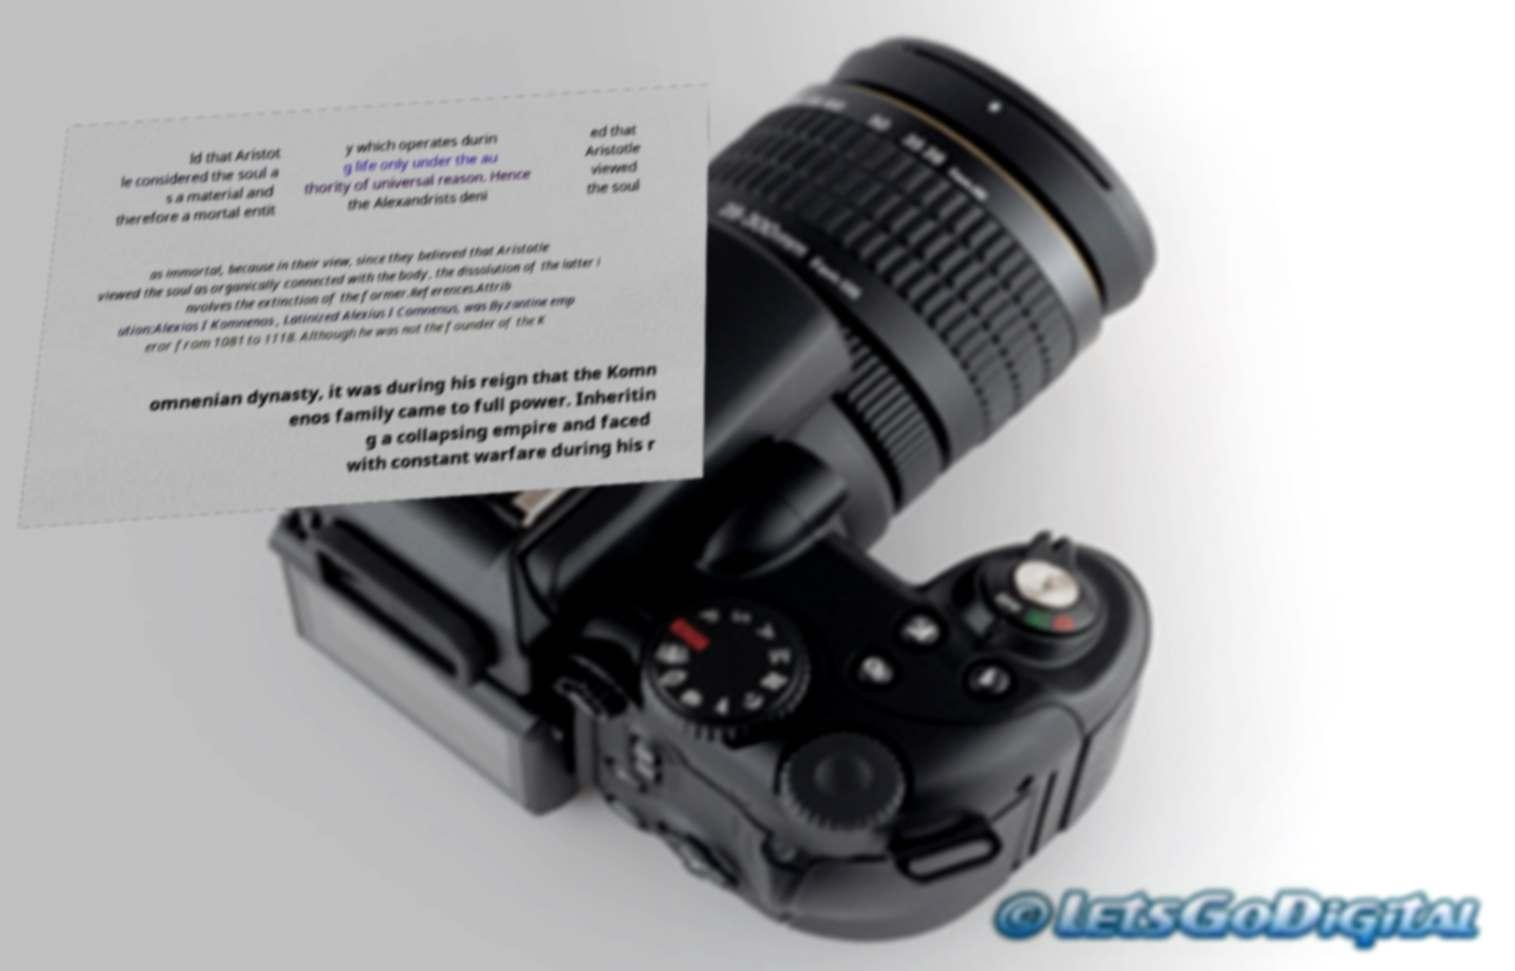Can you accurately transcribe the text from the provided image for me? ld that Aristot le considered the soul a s a material and therefore a mortal entit y which operates durin g life only under the au thority of universal reason. Hence the Alexandrists deni ed that Aristotle viewed the soul as immortal, because in their view, since they believed that Aristotle viewed the soul as organically connected with the body, the dissolution of the latter i nvolves the extinction of the former.References.Attrib ution:Alexios I Komnenos , Latinized Alexius I Comnenus, was Byzantine emp eror from 1081 to 1118. Although he was not the founder of the K omnenian dynasty, it was during his reign that the Komn enos family came to full power. Inheritin g a collapsing empire and faced with constant warfare during his r 